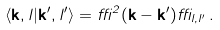<formula> <loc_0><loc_0><loc_500><loc_500>\langle { \mathbf k } , l | { \mathbf k } ^ { \prime } , l ^ { \prime } \rangle = \delta ^ { 2 } ( { \mathbf k } - { \mathbf k } ^ { \prime } ) \delta _ { l , l ^ { \prime } } \, .</formula> 